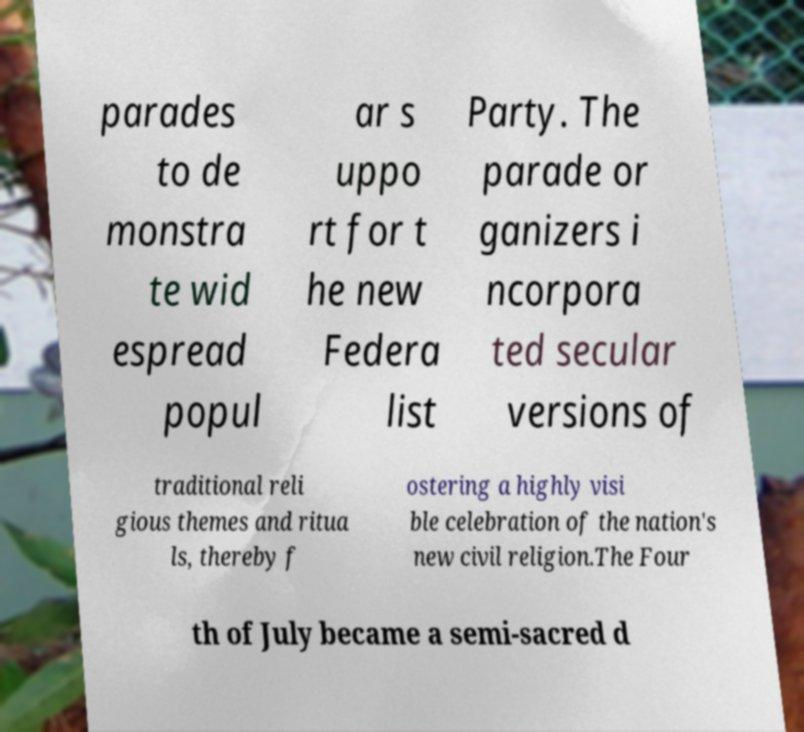Can you read and provide the text displayed in the image?This photo seems to have some interesting text. Can you extract and type it out for me? parades to de monstra te wid espread popul ar s uppo rt for t he new Federa list Party. The parade or ganizers i ncorpora ted secular versions of traditional reli gious themes and ritua ls, thereby f ostering a highly visi ble celebration of the nation's new civil religion.The Four th of July became a semi-sacred d 